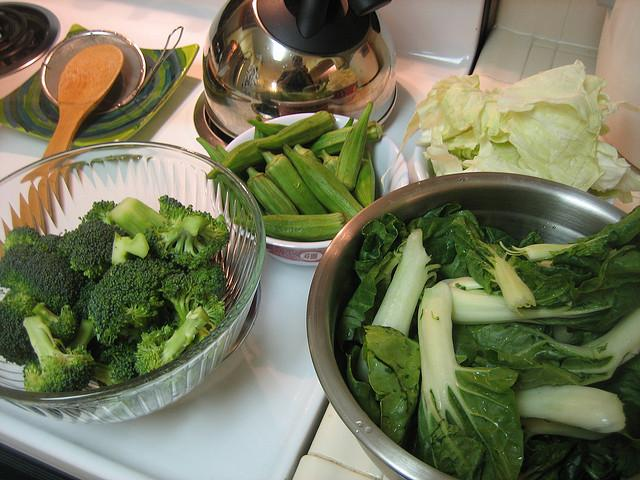What do all the foods being prepared have in common?

Choices:
A) vegetables
B) meat
C) dessert
D) dairy vegetables 